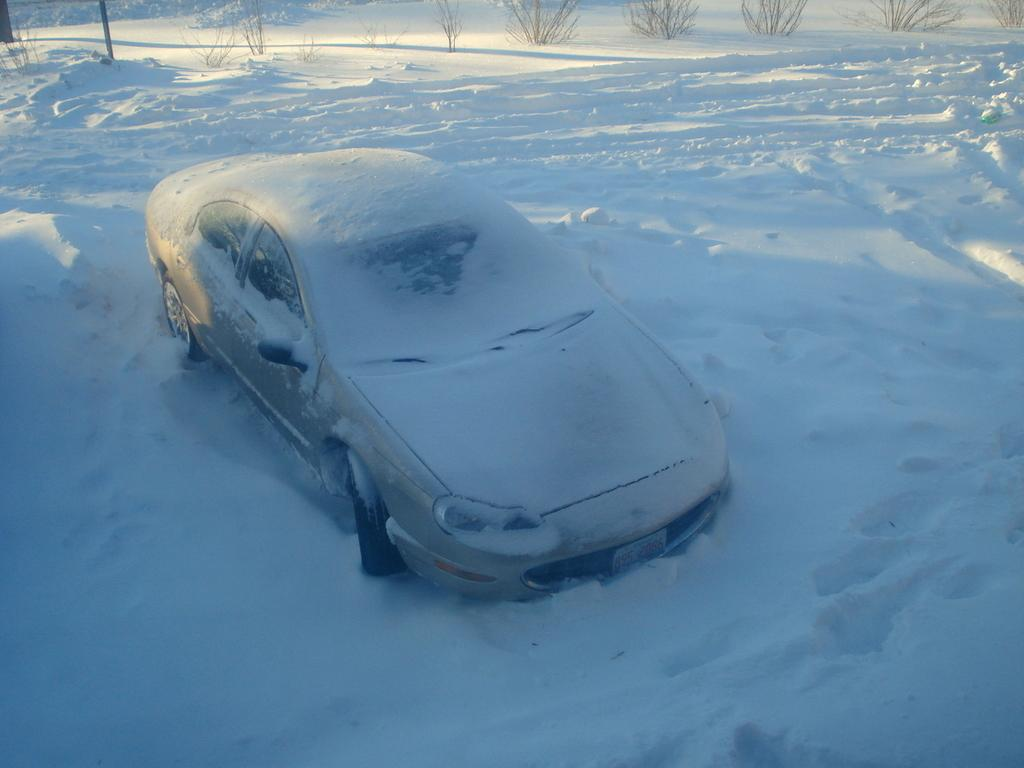What is the main subject of the image? The main subject of the image is a car. How is the car affected by the weather in the image? The car is covered with snow in the image. What can be seen in the background of the image? There is snow and plants visible in the background of the image. What force is being applied to the car by the sail in the image? There is no sail present in the image, and therefore no force is being applied to the car by a sail. 